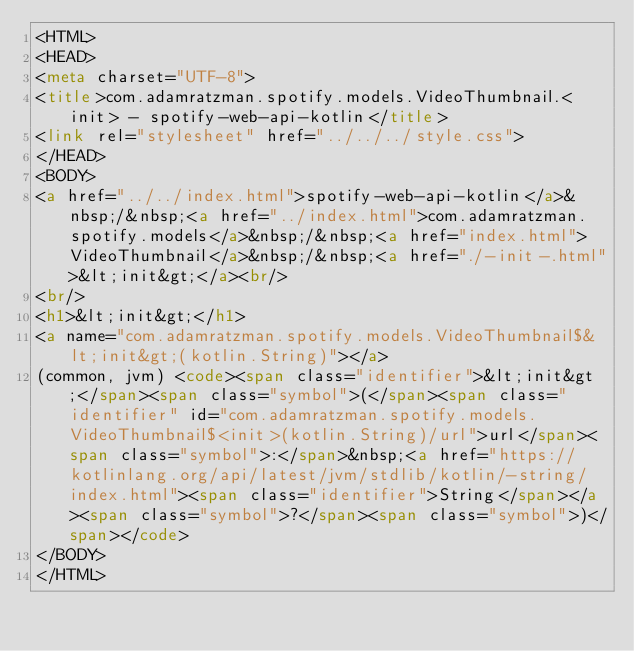<code> <loc_0><loc_0><loc_500><loc_500><_HTML_><HTML>
<HEAD>
<meta charset="UTF-8">
<title>com.adamratzman.spotify.models.VideoThumbnail.<init> - spotify-web-api-kotlin</title>
<link rel="stylesheet" href="../../../style.css">
</HEAD>
<BODY>
<a href="../../index.html">spotify-web-api-kotlin</a>&nbsp;/&nbsp;<a href="../index.html">com.adamratzman.spotify.models</a>&nbsp;/&nbsp;<a href="index.html">VideoThumbnail</a>&nbsp;/&nbsp;<a href="./-init-.html">&lt;init&gt;</a><br/>
<br/>
<h1>&lt;init&gt;</h1>
<a name="com.adamratzman.spotify.models.VideoThumbnail$&lt;init&gt;(kotlin.String)"></a>
(common, jvm) <code><span class="identifier">&lt;init&gt;</span><span class="symbol">(</span><span class="identifier" id="com.adamratzman.spotify.models.VideoThumbnail$<init>(kotlin.String)/url">url</span><span class="symbol">:</span>&nbsp;<a href="https://kotlinlang.org/api/latest/jvm/stdlib/kotlin/-string/index.html"><span class="identifier">String</span></a><span class="symbol">?</span><span class="symbol">)</span></code>
</BODY>
</HTML>
</code> 